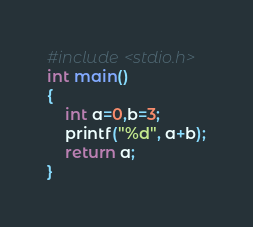<code> <loc_0><loc_0><loc_500><loc_500><_C_>#include <stdio.h>
int main()
{
    int a=0,b=3;
    printf("%d", a+b);
    return a;
}
</code> 